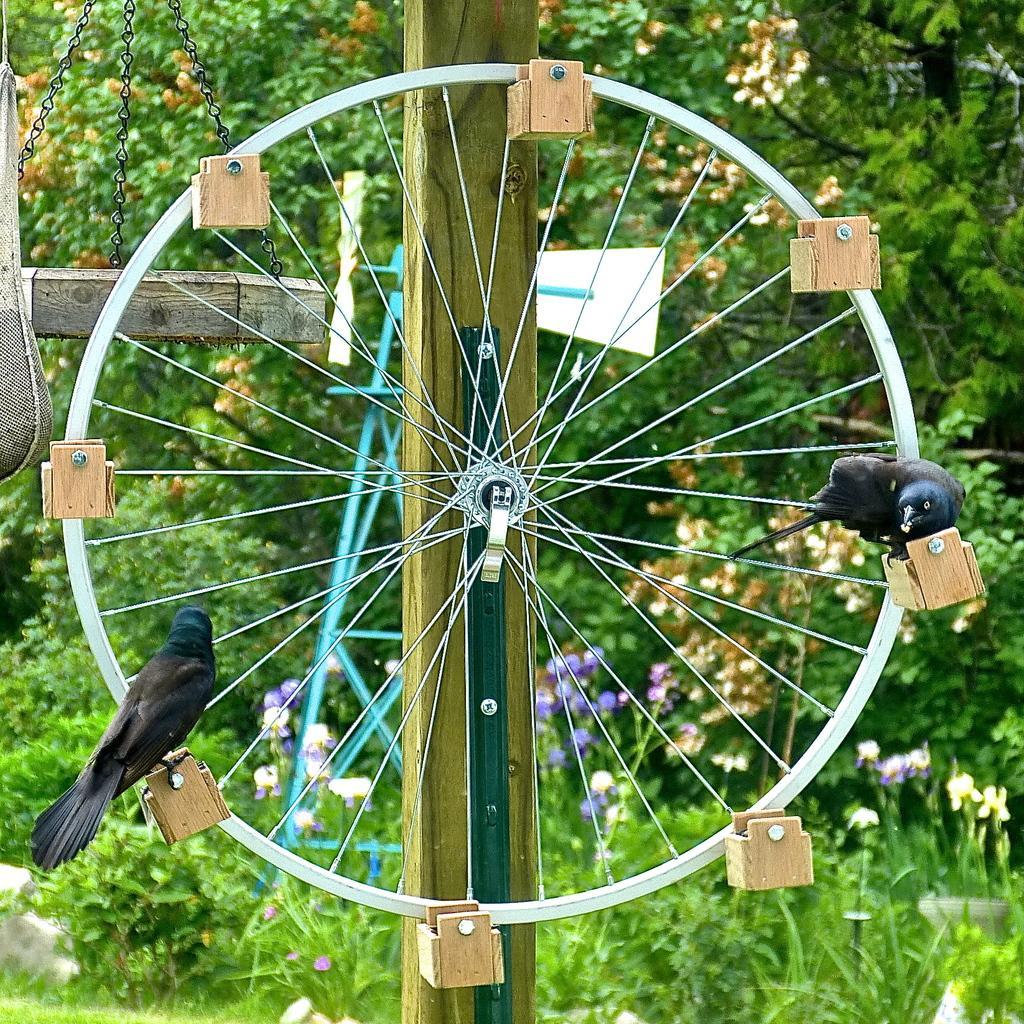Can you describe this image briefly? In this image I can see a wheel in the centre and on it I can see few wooden things and few black colour birds. In the background I can see flowers, grass and few trees. 